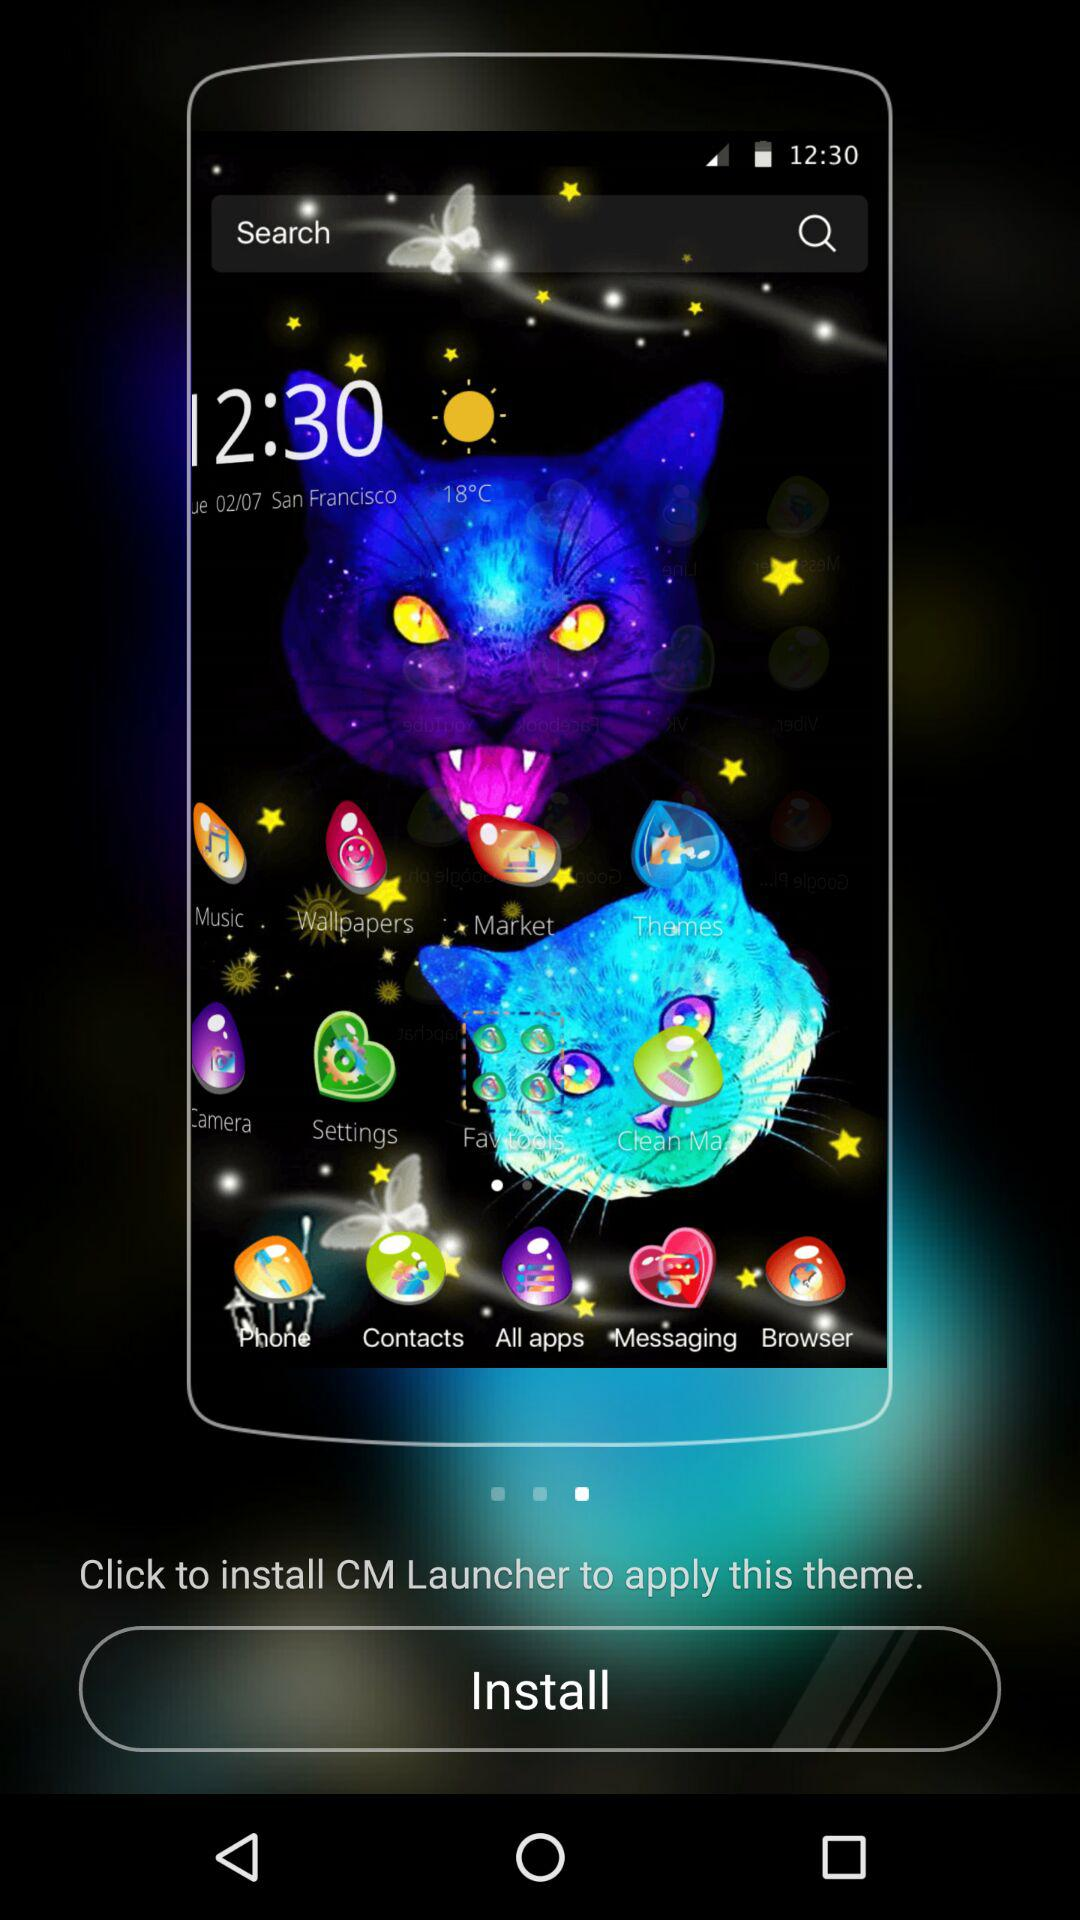What are the instructions for applying the theme? The instruction for applying the theme is "Click to install CM Launcher to apply this theme". 